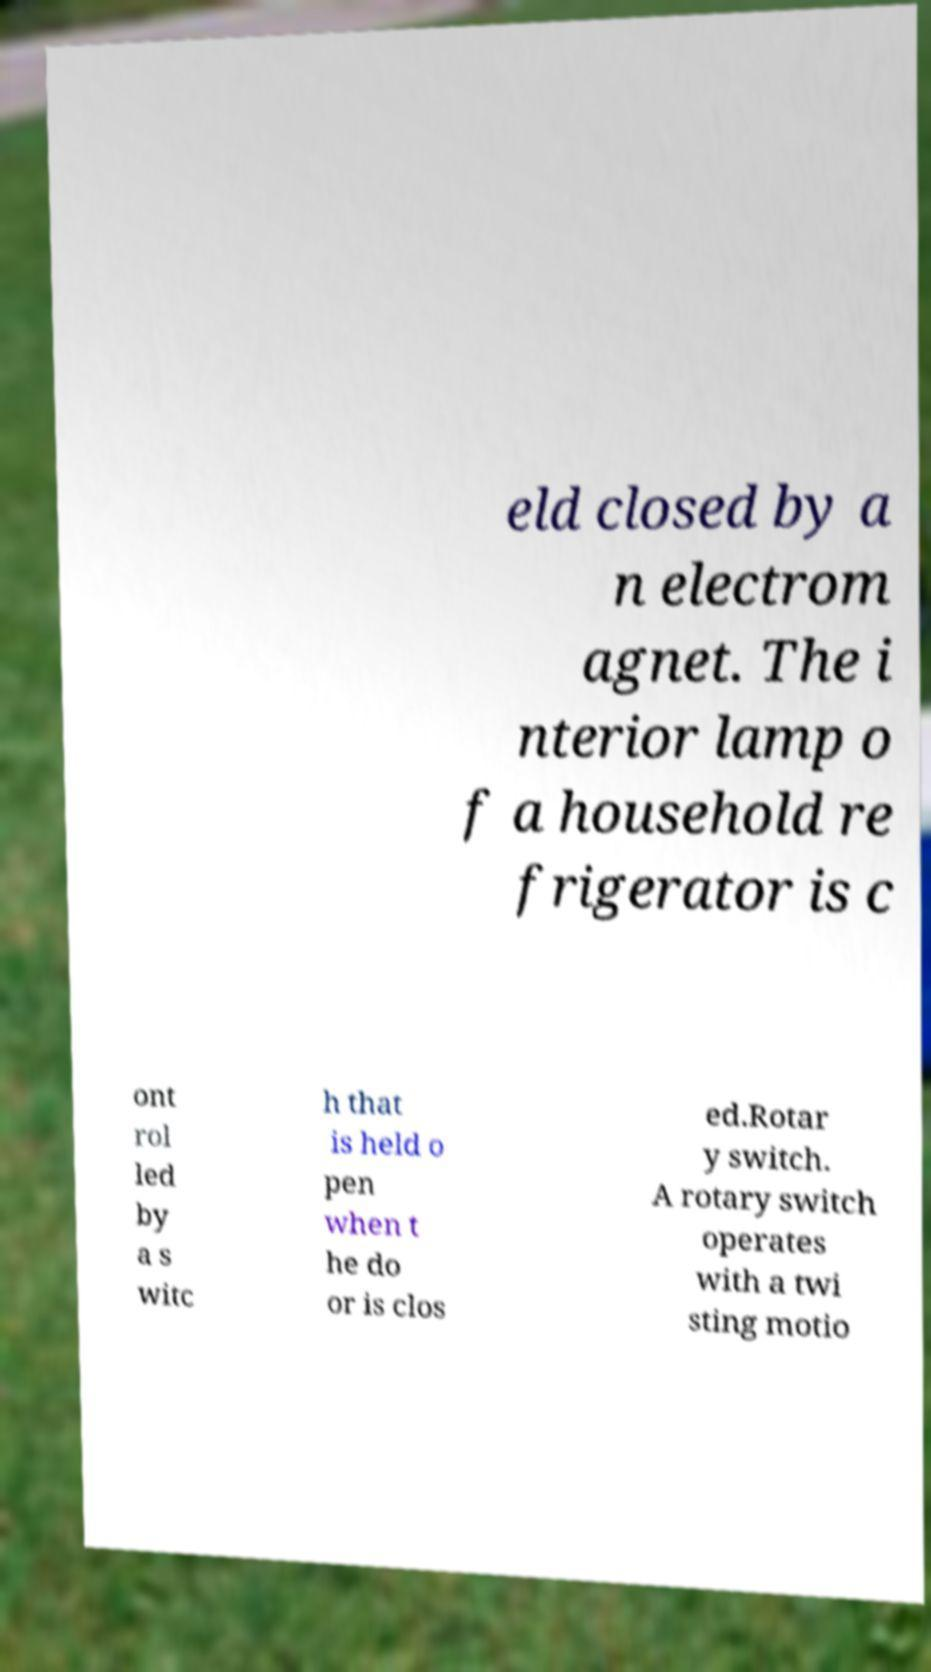What messages or text are displayed in this image? I need them in a readable, typed format. eld closed by a n electrom agnet. The i nterior lamp o f a household re frigerator is c ont rol led by a s witc h that is held o pen when t he do or is clos ed.Rotar y switch. A rotary switch operates with a twi sting motio 